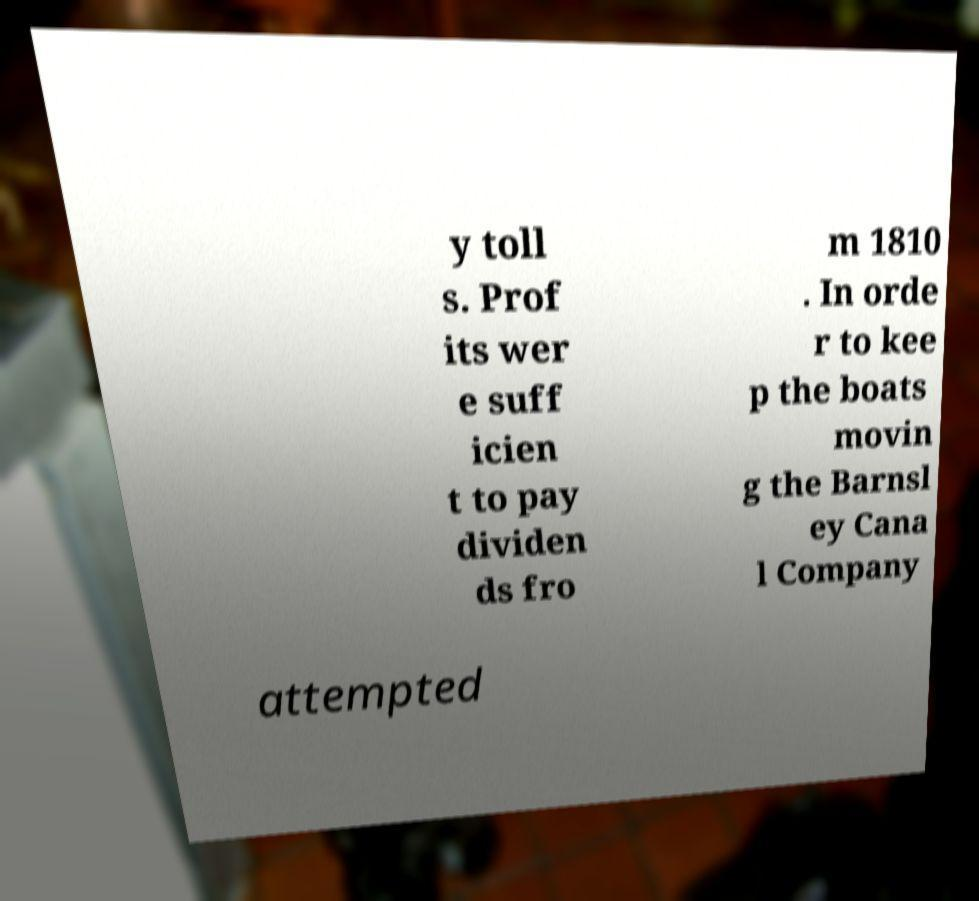Please identify and transcribe the text found in this image. y toll s. Prof its wer e suff icien t to pay dividen ds fro m 1810 . In orde r to kee p the boats movin g the Barnsl ey Cana l Company attempted 